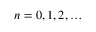<formula> <loc_0><loc_0><loc_500><loc_500>n = 0 , 1 , 2 , \dots</formula> 